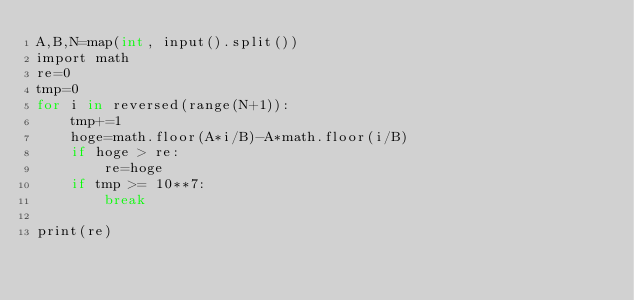Convert code to text. <code><loc_0><loc_0><loc_500><loc_500><_Cython_>A,B,N=map(int, input().split())
import math
re=0
tmp=0
for i in reversed(range(N+1)):
    tmp+=1
    hoge=math.floor(A*i/B)-A*math.floor(i/B)
    if hoge > re:
        re=hoge
    if tmp >= 10**7:
        break

print(re)</code> 